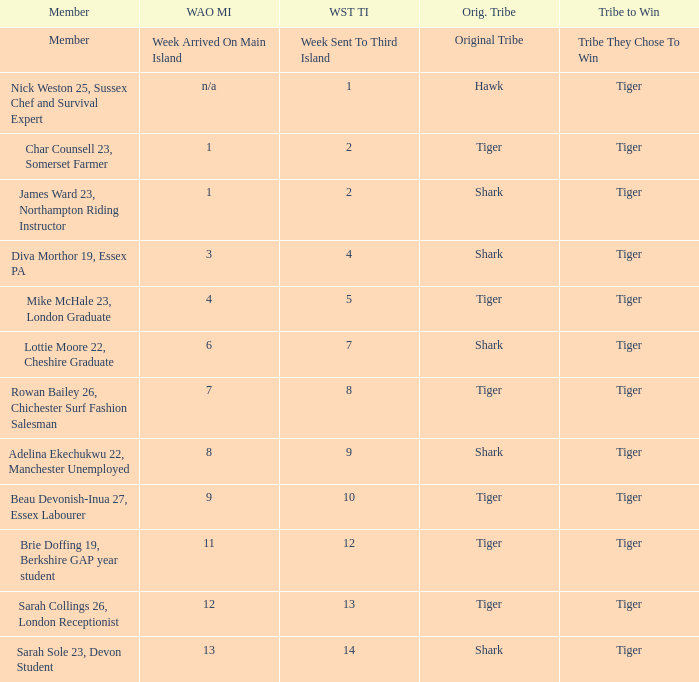How many members arrived on the main island in week 4? 1.0. 